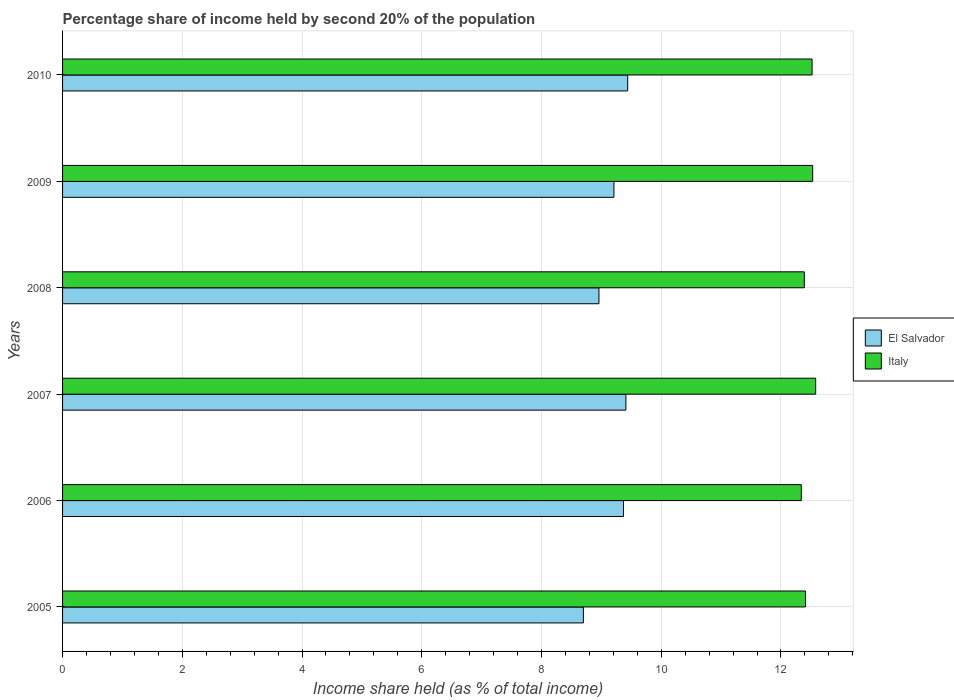How many different coloured bars are there?
Offer a very short reply. 2. How many bars are there on the 1st tick from the bottom?
Ensure brevity in your answer.  2. What is the label of the 2nd group of bars from the top?
Keep it short and to the point. 2009. Across all years, what is the maximum share of income held by second 20% of the population in Italy?
Your response must be concise. 12.58. Across all years, what is the minimum share of income held by second 20% of the population in Italy?
Ensure brevity in your answer.  12.34. In which year was the share of income held by second 20% of the population in Italy maximum?
Your answer should be compact. 2007. In which year was the share of income held by second 20% of the population in El Salvador minimum?
Your answer should be compact. 2005. What is the total share of income held by second 20% of the population in El Salvador in the graph?
Make the answer very short. 55.09. What is the difference between the share of income held by second 20% of the population in El Salvador in 2006 and that in 2009?
Give a very brief answer. 0.16. What is the difference between the share of income held by second 20% of the population in El Salvador in 2010 and the share of income held by second 20% of the population in Italy in 2009?
Provide a succinct answer. -3.09. What is the average share of income held by second 20% of the population in El Salvador per year?
Keep it short and to the point. 9.18. In the year 2005, what is the difference between the share of income held by second 20% of the population in El Salvador and share of income held by second 20% of the population in Italy?
Provide a short and direct response. -3.71. In how many years, is the share of income held by second 20% of the population in El Salvador greater than 10 %?
Give a very brief answer. 0. What is the ratio of the share of income held by second 20% of the population in El Salvador in 2008 to that in 2010?
Ensure brevity in your answer.  0.95. Is the share of income held by second 20% of the population in Italy in 2005 less than that in 2010?
Ensure brevity in your answer.  Yes. What is the difference between the highest and the second highest share of income held by second 20% of the population in El Salvador?
Offer a very short reply. 0.03. What is the difference between the highest and the lowest share of income held by second 20% of the population in Italy?
Make the answer very short. 0.24. In how many years, is the share of income held by second 20% of the population in Italy greater than the average share of income held by second 20% of the population in Italy taken over all years?
Make the answer very short. 3. Does the graph contain any zero values?
Offer a terse response. No. What is the title of the graph?
Keep it short and to the point. Percentage share of income held by second 20% of the population. What is the label or title of the X-axis?
Offer a terse response. Income share held (as % of total income). What is the label or title of the Y-axis?
Keep it short and to the point. Years. What is the Income share held (as % of total income) in El Salvador in 2005?
Ensure brevity in your answer.  8.7. What is the Income share held (as % of total income) of Italy in 2005?
Give a very brief answer. 12.41. What is the Income share held (as % of total income) of El Salvador in 2006?
Make the answer very short. 9.37. What is the Income share held (as % of total income) of Italy in 2006?
Provide a succinct answer. 12.34. What is the Income share held (as % of total income) of El Salvador in 2007?
Give a very brief answer. 9.41. What is the Income share held (as % of total income) of Italy in 2007?
Keep it short and to the point. 12.58. What is the Income share held (as % of total income) in El Salvador in 2008?
Offer a terse response. 8.96. What is the Income share held (as % of total income) in Italy in 2008?
Give a very brief answer. 12.39. What is the Income share held (as % of total income) in El Salvador in 2009?
Offer a very short reply. 9.21. What is the Income share held (as % of total income) of Italy in 2009?
Your response must be concise. 12.53. What is the Income share held (as % of total income) in El Salvador in 2010?
Ensure brevity in your answer.  9.44. What is the Income share held (as % of total income) of Italy in 2010?
Make the answer very short. 12.52. Across all years, what is the maximum Income share held (as % of total income) in El Salvador?
Provide a short and direct response. 9.44. Across all years, what is the maximum Income share held (as % of total income) of Italy?
Provide a short and direct response. 12.58. Across all years, what is the minimum Income share held (as % of total income) of Italy?
Your answer should be compact. 12.34. What is the total Income share held (as % of total income) in El Salvador in the graph?
Provide a short and direct response. 55.09. What is the total Income share held (as % of total income) in Italy in the graph?
Ensure brevity in your answer.  74.77. What is the difference between the Income share held (as % of total income) in El Salvador in 2005 and that in 2006?
Give a very brief answer. -0.67. What is the difference between the Income share held (as % of total income) in Italy in 2005 and that in 2006?
Make the answer very short. 0.07. What is the difference between the Income share held (as % of total income) in El Salvador in 2005 and that in 2007?
Offer a very short reply. -0.71. What is the difference between the Income share held (as % of total income) of Italy in 2005 and that in 2007?
Your answer should be compact. -0.17. What is the difference between the Income share held (as % of total income) in El Salvador in 2005 and that in 2008?
Make the answer very short. -0.26. What is the difference between the Income share held (as % of total income) of Italy in 2005 and that in 2008?
Your answer should be very brief. 0.02. What is the difference between the Income share held (as % of total income) in El Salvador in 2005 and that in 2009?
Your answer should be compact. -0.51. What is the difference between the Income share held (as % of total income) in Italy in 2005 and that in 2009?
Keep it short and to the point. -0.12. What is the difference between the Income share held (as % of total income) of El Salvador in 2005 and that in 2010?
Offer a terse response. -0.74. What is the difference between the Income share held (as % of total income) in Italy in 2005 and that in 2010?
Your answer should be very brief. -0.11. What is the difference between the Income share held (as % of total income) in El Salvador in 2006 and that in 2007?
Your answer should be very brief. -0.04. What is the difference between the Income share held (as % of total income) in Italy in 2006 and that in 2007?
Your answer should be very brief. -0.24. What is the difference between the Income share held (as % of total income) in El Salvador in 2006 and that in 2008?
Your answer should be compact. 0.41. What is the difference between the Income share held (as % of total income) in El Salvador in 2006 and that in 2009?
Offer a terse response. 0.16. What is the difference between the Income share held (as % of total income) in Italy in 2006 and that in 2009?
Make the answer very short. -0.19. What is the difference between the Income share held (as % of total income) of El Salvador in 2006 and that in 2010?
Offer a very short reply. -0.07. What is the difference between the Income share held (as % of total income) of Italy in 2006 and that in 2010?
Your response must be concise. -0.18. What is the difference between the Income share held (as % of total income) in El Salvador in 2007 and that in 2008?
Give a very brief answer. 0.45. What is the difference between the Income share held (as % of total income) of Italy in 2007 and that in 2008?
Offer a terse response. 0.19. What is the difference between the Income share held (as % of total income) of El Salvador in 2007 and that in 2010?
Your answer should be very brief. -0.03. What is the difference between the Income share held (as % of total income) of El Salvador in 2008 and that in 2009?
Your answer should be compact. -0.25. What is the difference between the Income share held (as % of total income) in Italy in 2008 and that in 2009?
Ensure brevity in your answer.  -0.14. What is the difference between the Income share held (as % of total income) of El Salvador in 2008 and that in 2010?
Provide a succinct answer. -0.48. What is the difference between the Income share held (as % of total income) in Italy in 2008 and that in 2010?
Your answer should be compact. -0.13. What is the difference between the Income share held (as % of total income) of El Salvador in 2009 and that in 2010?
Offer a terse response. -0.23. What is the difference between the Income share held (as % of total income) in El Salvador in 2005 and the Income share held (as % of total income) in Italy in 2006?
Give a very brief answer. -3.64. What is the difference between the Income share held (as % of total income) of El Salvador in 2005 and the Income share held (as % of total income) of Italy in 2007?
Your answer should be very brief. -3.88. What is the difference between the Income share held (as % of total income) of El Salvador in 2005 and the Income share held (as % of total income) of Italy in 2008?
Your answer should be very brief. -3.69. What is the difference between the Income share held (as % of total income) in El Salvador in 2005 and the Income share held (as % of total income) in Italy in 2009?
Ensure brevity in your answer.  -3.83. What is the difference between the Income share held (as % of total income) of El Salvador in 2005 and the Income share held (as % of total income) of Italy in 2010?
Offer a very short reply. -3.82. What is the difference between the Income share held (as % of total income) of El Salvador in 2006 and the Income share held (as % of total income) of Italy in 2007?
Your response must be concise. -3.21. What is the difference between the Income share held (as % of total income) of El Salvador in 2006 and the Income share held (as % of total income) of Italy in 2008?
Your response must be concise. -3.02. What is the difference between the Income share held (as % of total income) of El Salvador in 2006 and the Income share held (as % of total income) of Italy in 2009?
Make the answer very short. -3.16. What is the difference between the Income share held (as % of total income) of El Salvador in 2006 and the Income share held (as % of total income) of Italy in 2010?
Give a very brief answer. -3.15. What is the difference between the Income share held (as % of total income) of El Salvador in 2007 and the Income share held (as % of total income) of Italy in 2008?
Provide a short and direct response. -2.98. What is the difference between the Income share held (as % of total income) of El Salvador in 2007 and the Income share held (as % of total income) of Italy in 2009?
Give a very brief answer. -3.12. What is the difference between the Income share held (as % of total income) of El Salvador in 2007 and the Income share held (as % of total income) of Italy in 2010?
Keep it short and to the point. -3.11. What is the difference between the Income share held (as % of total income) of El Salvador in 2008 and the Income share held (as % of total income) of Italy in 2009?
Provide a short and direct response. -3.57. What is the difference between the Income share held (as % of total income) in El Salvador in 2008 and the Income share held (as % of total income) in Italy in 2010?
Ensure brevity in your answer.  -3.56. What is the difference between the Income share held (as % of total income) in El Salvador in 2009 and the Income share held (as % of total income) in Italy in 2010?
Your answer should be compact. -3.31. What is the average Income share held (as % of total income) of El Salvador per year?
Provide a short and direct response. 9.18. What is the average Income share held (as % of total income) in Italy per year?
Offer a terse response. 12.46. In the year 2005, what is the difference between the Income share held (as % of total income) of El Salvador and Income share held (as % of total income) of Italy?
Make the answer very short. -3.71. In the year 2006, what is the difference between the Income share held (as % of total income) in El Salvador and Income share held (as % of total income) in Italy?
Provide a succinct answer. -2.97. In the year 2007, what is the difference between the Income share held (as % of total income) of El Salvador and Income share held (as % of total income) of Italy?
Give a very brief answer. -3.17. In the year 2008, what is the difference between the Income share held (as % of total income) in El Salvador and Income share held (as % of total income) in Italy?
Make the answer very short. -3.43. In the year 2009, what is the difference between the Income share held (as % of total income) of El Salvador and Income share held (as % of total income) of Italy?
Make the answer very short. -3.32. In the year 2010, what is the difference between the Income share held (as % of total income) in El Salvador and Income share held (as % of total income) in Italy?
Ensure brevity in your answer.  -3.08. What is the ratio of the Income share held (as % of total income) of El Salvador in 2005 to that in 2006?
Offer a terse response. 0.93. What is the ratio of the Income share held (as % of total income) of El Salvador in 2005 to that in 2007?
Keep it short and to the point. 0.92. What is the ratio of the Income share held (as % of total income) of Italy in 2005 to that in 2007?
Ensure brevity in your answer.  0.99. What is the ratio of the Income share held (as % of total income) of El Salvador in 2005 to that in 2009?
Provide a succinct answer. 0.94. What is the ratio of the Income share held (as % of total income) of Italy in 2005 to that in 2009?
Provide a succinct answer. 0.99. What is the ratio of the Income share held (as % of total income) of El Salvador in 2005 to that in 2010?
Make the answer very short. 0.92. What is the ratio of the Income share held (as % of total income) in El Salvador in 2006 to that in 2007?
Make the answer very short. 1. What is the ratio of the Income share held (as % of total income) in Italy in 2006 to that in 2007?
Your answer should be very brief. 0.98. What is the ratio of the Income share held (as % of total income) in El Salvador in 2006 to that in 2008?
Offer a terse response. 1.05. What is the ratio of the Income share held (as % of total income) in Italy in 2006 to that in 2008?
Provide a short and direct response. 1. What is the ratio of the Income share held (as % of total income) in El Salvador in 2006 to that in 2009?
Make the answer very short. 1.02. What is the ratio of the Income share held (as % of total income) of Italy in 2006 to that in 2009?
Give a very brief answer. 0.98. What is the ratio of the Income share held (as % of total income) of El Salvador in 2006 to that in 2010?
Keep it short and to the point. 0.99. What is the ratio of the Income share held (as % of total income) of Italy in 2006 to that in 2010?
Ensure brevity in your answer.  0.99. What is the ratio of the Income share held (as % of total income) in El Salvador in 2007 to that in 2008?
Make the answer very short. 1.05. What is the ratio of the Income share held (as % of total income) of Italy in 2007 to that in 2008?
Provide a short and direct response. 1.02. What is the ratio of the Income share held (as % of total income) of El Salvador in 2007 to that in 2009?
Your response must be concise. 1.02. What is the ratio of the Income share held (as % of total income) of Italy in 2007 to that in 2009?
Offer a very short reply. 1. What is the ratio of the Income share held (as % of total income) of El Salvador in 2008 to that in 2009?
Your answer should be compact. 0.97. What is the ratio of the Income share held (as % of total income) in El Salvador in 2008 to that in 2010?
Provide a succinct answer. 0.95. What is the ratio of the Income share held (as % of total income) in El Salvador in 2009 to that in 2010?
Your response must be concise. 0.98. What is the difference between the highest and the second highest Income share held (as % of total income) in El Salvador?
Give a very brief answer. 0.03. What is the difference between the highest and the lowest Income share held (as % of total income) of El Salvador?
Give a very brief answer. 0.74. What is the difference between the highest and the lowest Income share held (as % of total income) of Italy?
Offer a very short reply. 0.24. 